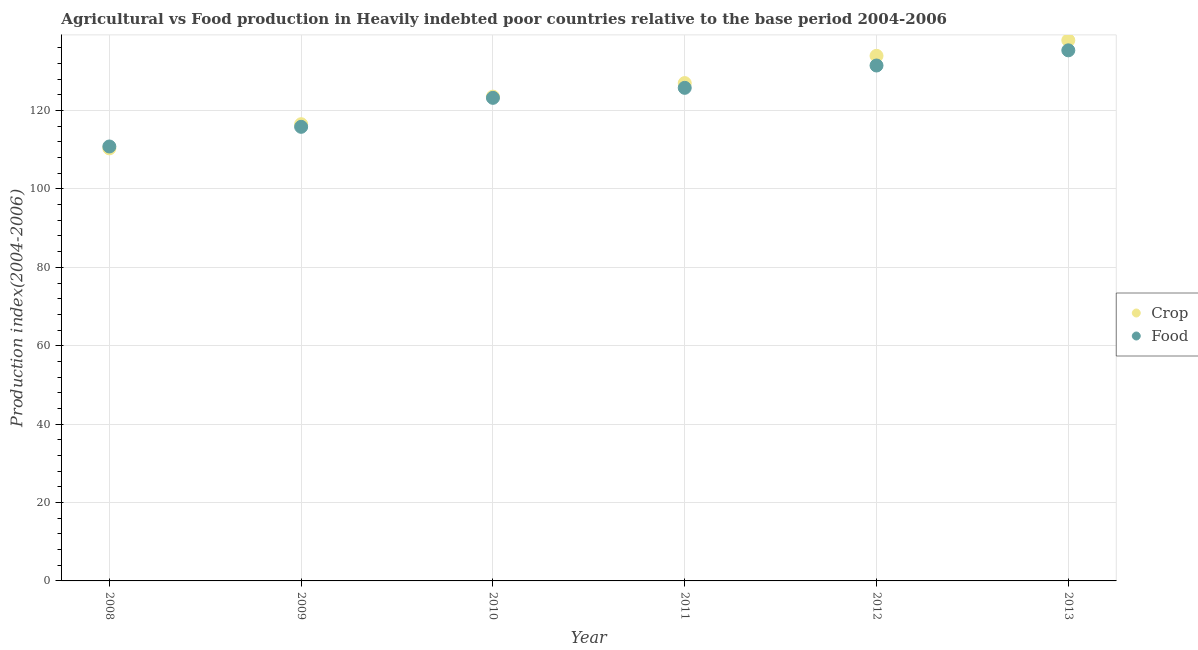How many different coloured dotlines are there?
Your answer should be very brief. 2. Is the number of dotlines equal to the number of legend labels?
Your response must be concise. Yes. What is the crop production index in 2010?
Offer a very short reply. 123.54. Across all years, what is the maximum food production index?
Give a very brief answer. 135.35. Across all years, what is the minimum crop production index?
Your response must be concise. 110.35. In which year was the food production index minimum?
Provide a succinct answer. 2008. What is the total food production index in the graph?
Ensure brevity in your answer.  742.53. What is the difference between the food production index in 2008 and that in 2013?
Provide a short and direct response. -24.53. What is the difference between the crop production index in 2013 and the food production index in 2008?
Keep it short and to the point. 27.09. What is the average food production index per year?
Offer a terse response. 123.75. In the year 2008, what is the difference between the crop production index and food production index?
Ensure brevity in your answer.  -0.48. What is the ratio of the food production index in 2009 to that in 2010?
Provide a succinct answer. 0.94. Is the crop production index in 2009 less than that in 2010?
Provide a short and direct response. Yes. What is the difference between the highest and the second highest food production index?
Your answer should be compact. 3.87. What is the difference between the highest and the lowest crop production index?
Provide a succinct answer. 27.57. In how many years, is the food production index greater than the average food production index taken over all years?
Your response must be concise. 3. Does the crop production index monotonically increase over the years?
Offer a terse response. Yes. Is the crop production index strictly greater than the food production index over the years?
Ensure brevity in your answer.  No. Is the food production index strictly less than the crop production index over the years?
Your answer should be compact. No. How many years are there in the graph?
Offer a very short reply. 6. What is the difference between two consecutive major ticks on the Y-axis?
Provide a short and direct response. 20. Are the values on the major ticks of Y-axis written in scientific E-notation?
Keep it short and to the point. No. How many legend labels are there?
Make the answer very short. 2. How are the legend labels stacked?
Make the answer very short. Vertical. What is the title of the graph?
Offer a very short reply. Agricultural vs Food production in Heavily indebted poor countries relative to the base period 2004-2006. Does "Largest city" appear as one of the legend labels in the graph?
Your answer should be compact. No. What is the label or title of the Y-axis?
Your answer should be very brief. Production index(2004-2006). What is the Production index(2004-2006) in Crop in 2008?
Provide a short and direct response. 110.35. What is the Production index(2004-2006) of Food in 2008?
Offer a terse response. 110.83. What is the Production index(2004-2006) of Crop in 2009?
Provide a short and direct response. 116.51. What is the Production index(2004-2006) of Food in 2009?
Your answer should be very brief. 115.84. What is the Production index(2004-2006) of Crop in 2010?
Provide a short and direct response. 123.54. What is the Production index(2004-2006) in Food in 2010?
Give a very brief answer. 123.23. What is the Production index(2004-2006) in Crop in 2011?
Give a very brief answer. 127. What is the Production index(2004-2006) in Food in 2011?
Your answer should be very brief. 125.79. What is the Production index(2004-2006) of Crop in 2012?
Give a very brief answer. 133.95. What is the Production index(2004-2006) in Food in 2012?
Your response must be concise. 131.48. What is the Production index(2004-2006) in Crop in 2013?
Give a very brief answer. 137.92. What is the Production index(2004-2006) in Food in 2013?
Offer a very short reply. 135.35. Across all years, what is the maximum Production index(2004-2006) in Crop?
Keep it short and to the point. 137.92. Across all years, what is the maximum Production index(2004-2006) of Food?
Your answer should be very brief. 135.35. Across all years, what is the minimum Production index(2004-2006) of Crop?
Provide a succinct answer. 110.35. Across all years, what is the minimum Production index(2004-2006) of Food?
Your answer should be very brief. 110.83. What is the total Production index(2004-2006) in Crop in the graph?
Offer a terse response. 749.27. What is the total Production index(2004-2006) in Food in the graph?
Offer a very short reply. 742.53. What is the difference between the Production index(2004-2006) of Crop in 2008 and that in 2009?
Give a very brief answer. -6.17. What is the difference between the Production index(2004-2006) in Food in 2008 and that in 2009?
Your response must be concise. -5.01. What is the difference between the Production index(2004-2006) in Crop in 2008 and that in 2010?
Give a very brief answer. -13.2. What is the difference between the Production index(2004-2006) of Food in 2008 and that in 2010?
Ensure brevity in your answer.  -12.41. What is the difference between the Production index(2004-2006) in Crop in 2008 and that in 2011?
Ensure brevity in your answer.  -16.65. What is the difference between the Production index(2004-2006) of Food in 2008 and that in 2011?
Make the answer very short. -14.96. What is the difference between the Production index(2004-2006) of Crop in 2008 and that in 2012?
Offer a terse response. -23.61. What is the difference between the Production index(2004-2006) in Food in 2008 and that in 2012?
Offer a terse response. -20.65. What is the difference between the Production index(2004-2006) in Crop in 2008 and that in 2013?
Your answer should be very brief. -27.57. What is the difference between the Production index(2004-2006) of Food in 2008 and that in 2013?
Ensure brevity in your answer.  -24.53. What is the difference between the Production index(2004-2006) in Crop in 2009 and that in 2010?
Your response must be concise. -7.03. What is the difference between the Production index(2004-2006) in Food in 2009 and that in 2010?
Your answer should be very brief. -7.39. What is the difference between the Production index(2004-2006) of Crop in 2009 and that in 2011?
Provide a short and direct response. -10.49. What is the difference between the Production index(2004-2006) in Food in 2009 and that in 2011?
Make the answer very short. -9.95. What is the difference between the Production index(2004-2006) of Crop in 2009 and that in 2012?
Provide a succinct answer. -17.44. What is the difference between the Production index(2004-2006) of Food in 2009 and that in 2012?
Keep it short and to the point. -15.64. What is the difference between the Production index(2004-2006) in Crop in 2009 and that in 2013?
Your response must be concise. -21.41. What is the difference between the Production index(2004-2006) in Food in 2009 and that in 2013?
Give a very brief answer. -19.51. What is the difference between the Production index(2004-2006) in Crop in 2010 and that in 2011?
Make the answer very short. -3.46. What is the difference between the Production index(2004-2006) in Food in 2010 and that in 2011?
Offer a terse response. -2.55. What is the difference between the Production index(2004-2006) of Crop in 2010 and that in 2012?
Keep it short and to the point. -10.41. What is the difference between the Production index(2004-2006) of Food in 2010 and that in 2012?
Ensure brevity in your answer.  -8.25. What is the difference between the Production index(2004-2006) of Crop in 2010 and that in 2013?
Your response must be concise. -14.38. What is the difference between the Production index(2004-2006) in Food in 2010 and that in 2013?
Provide a succinct answer. -12.12. What is the difference between the Production index(2004-2006) of Crop in 2011 and that in 2012?
Your answer should be very brief. -6.95. What is the difference between the Production index(2004-2006) of Food in 2011 and that in 2012?
Offer a very short reply. -5.7. What is the difference between the Production index(2004-2006) of Crop in 2011 and that in 2013?
Provide a short and direct response. -10.92. What is the difference between the Production index(2004-2006) in Food in 2011 and that in 2013?
Offer a very short reply. -9.57. What is the difference between the Production index(2004-2006) in Crop in 2012 and that in 2013?
Ensure brevity in your answer.  -3.97. What is the difference between the Production index(2004-2006) in Food in 2012 and that in 2013?
Your answer should be compact. -3.87. What is the difference between the Production index(2004-2006) of Crop in 2008 and the Production index(2004-2006) of Food in 2009?
Your answer should be very brief. -5.5. What is the difference between the Production index(2004-2006) of Crop in 2008 and the Production index(2004-2006) of Food in 2010?
Offer a terse response. -12.89. What is the difference between the Production index(2004-2006) in Crop in 2008 and the Production index(2004-2006) in Food in 2011?
Ensure brevity in your answer.  -15.44. What is the difference between the Production index(2004-2006) in Crop in 2008 and the Production index(2004-2006) in Food in 2012?
Your response must be concise. -21.14. What is the difference between the Production index(2004-2006) of Crop in 2008 and the Production index(2004-2006) of Food in 2013?
Provide a short and direct response. -25.01. What is the difference between the Production index(2004-2006) of Crop in 2009 and the Production index(2004-2006) of Food in 2010?
Keep it short and to the point. -6.72. What is the difference between the Production index(2004-2006) in Crop in 2009 and the Production index(2004-2006) in Food in 2011?
Your answer should be compact. -9.28. What is the difference between the Production index(2004-2006) in Crop in 2009 and the Production index(2004-2006) in Food in 2012?
Offer a terse response. -14.97. What is the difference between the Production index(2004-2006) of Crop in 2009 and the Production index(2004-2006) of Food in 2013?
Give a very brief answer. -18.84. What is the difference between the Production index(2004-2006) of Crop in 2010 and the Production index(2004-2006) of Food in 2011?
Offer a very short reply. -2.24. What is the difference between the Production index(2004-2006) in Crop in 2010 and the Production index(2004-2006) in Food in 2012?
Provide a succinct answer. -7.94. What is the difference between the Production index(2004-2006) of Crop in 2010 and the Production index(2004-2006) of Food in 2013?
Your response must be concise. -11.81. What is the difference between the Production index(2004-2006) in Crop in 2011 and the Production index(2004-2006) in Food in 2012?
Provide a short and direct response. -4.48. What is the difference between the Production index(2004-2006) of Crop in 2011 and the Production index(2004-2006) of Food in 2013?
Offer a terse response. -8.36. What is the difference between the Production index(2004-2006) in Crop in 2012 and the Production index(2004-2006) in Food in 2013?
Your response must be concise. -1.4. What is the average Production index(2004-2006) of Crop per year?
Offer a terse response. 124.88. What is the average Production index(2004-2006) of Food per year?
Your answer should be compact. 123.75. In the year 2008, what is the difference between the Production index(2004-2006) in Crop and Production index(2004-2006) in Food?
Provide a short and direct response. -0.48. In the year 2009, what is the difference between the Production index(2004-2006) in Crop and Production index(2004-2006) in Food?
Offer a very short reply. 0.67. In the year 2010, what is the difference between the Production index(2004-2006) of Crop and Production index(2004-2006) of Food?
Give a very brief answer. 0.31. In the year 2011, what is the difference between the Production index(2004-2006) of Crop and Production index(2004-2006) of Food?
Your answer should be compact. 1.21. In the year 2012, what is the difference between the Production index(2004-2006) of Crop and Production index(2004-2006) of Food?
Offer a terse response. 2.47. In the year 2013, what is the difference between the Production index(2004-2006) in Crop and Production index(2004-2006) in Food?
Give a very brief answer. 2.57. What is the ratio of the Production index(2004-2006) of Crop in 2008 to that in 2009?
Offer a terse response. 0.95. What is the ratio of the Production index(2004-2006) of Food in 2008 to that in 2009?
Make the answer very short. 0.96. What is the ratio of the Production index(2004-2006) of Crop in 2008 to that in 2010?
Ensure brevity in your answer.  0.89. What is the ratio of the Production index(2004-2006) in Food in 2008 to that in 2010?
Ensure brevity in your answer.  0.9. What is the ratio of the Production index(2004-2006) of Crop in 2008 to that in 2011?
Your response must be concise. 0.87. What is the ratio of the Production index(2004-2006) in Food in 2008 to that in 2011?
Offer a terse response. 0.88. What is the ratio of the Production index(2004-2006) in Crop in 2008 to that in 2012?
Your answer should be very brief. 0.82. What is the ratio of the Production index(2004-2006) of Food in 2008 to that in 2012?
Your answer should be very brief. 0.84. What is the ratio of the Production index(2004-2006) of Crop in 2008 to that in 2013?
Make the answer very short. 0.8. What is the ratio of the Production index(2004-2006) of Food in 2008 to that in 2013?
Your answer should be very brief. 0.82. What is the ratio of the Production index(2004-2006) in Crop in 2009 to that in 2010?
Offer a very short reply. 0.94. What is the ratio of the Production index(2004-2006) of Food in 2009 to that in 2010?
Offer a very short reply. 0.94. What is the ratio of the Production index(2004-2006) of Crop in 2009 to that in 2011?
Offer a terse response. 0.92. What is the ratio of the Production index(2004-2006) of Food in 2009 to that in 2011?
Your response must be concise. 0.92. What is the ratio of the Production index(2004-2006) of Crop in 2009 to that in 2012?
Ensure brevity in your answer.  0.87. What is the ratio of the Production index(2004-2006) of Food in 2009 to that in 2012?
Provide a short and direct response. 0.88. What is the ratio of the Production index(2004-2006) of Crop in 2009 to that in 2013?
Offer a very short reply. 0.84. What is the ratio of the Production index(2004-2006) of Food in 2009 to that in 2013?
Provide a succinct answer. 0.86. What is the ratio of the Production index(2004-2006) of Crop in 2010 to that in 2011?
Offer a very short reply. 0.97. What is the ratio of the Production index(2004-2006) of Food in 2010 to that in 2011?
Your response must be concise. 0.98. What is the ratio of the Production index(2004-2006) in Crop in 2010 to that in 2012?
Make the answer very short. 0.92. What is the ratio of the Production index(2004-2006) in Food in 2010 to that in 2012?
Your response must be concise. 0.94. What is the ratio of the Production index(2004-2006) in Crop in 2010 to that in 2013?
Give a very brief answer. 0.9. What is the ratio of the Production index(2004-2006) in Food in 2010 to that in 2013?
Give a very brief answer. 0.91. What is the ratio of the Production index(2004-2006) in Crop in 2011 to that in 2012?
Make the answer very short. 0.95. What is the ratio of the Production index(2004-2006) in Food in 2011 to that in 2012?
Give a very brief answer. 0.96. What is the ratio of the Production index(2004-2006) in Crop in 2011 to that in 2013?
Provide a short and direct response. 0.92. What is the ratio of the Production index(2004-2006) in Food in 2011 to that in 2013?
Your answer should be very brief. 0.93. What is the ratio of the Production index(2004-2006) of Crop in 2012 to that in 2013?
Provide a succinct answer. 0.97. What is the ratio of the Production index(2004-2006) in Food in 2012 to that in 2013?
Offer a terse response. 0.97. What is the difference between the highest and the second highest Production index(2004-2006) of Crop?
Your answer should be very brief. 3.97. What is the difference between the highest and the second highest Production index(2004-2006) of Food?
Make the answer very short. 3.87. What is the difference between the highest and the lowest Production index(2004-2006) of Crop?
Provide a short and direct response. 27.57. What is the difference between the highest and the lowest Production index(2004-2006) in Food?
Provide a short and direct response. 24.53. 